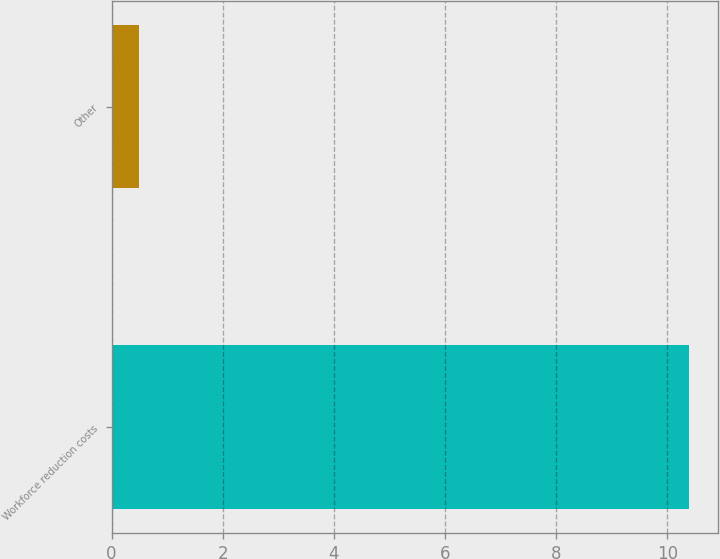Convert chart. <chart><loc_0><loc_0><loc_500><loc_500><bar_chart><fcel>Workforce reduction costs<fcel>Other<nl><fcel>10.4<fcel>0.5<nl></chart> 